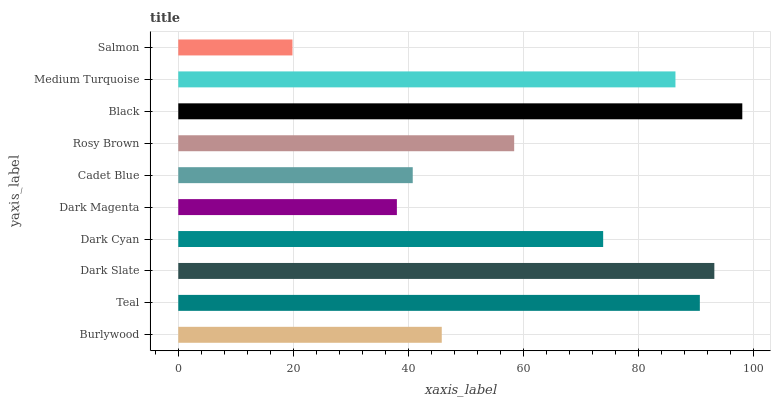Is Salmon the minimum?
Answer yes or no. Yes. Is Black the maximum?
Answer yes or no. Yes. Is Teal the minimum?
Answer yes or no. No. Is Teal the maximum?
Answer yes or no. No. Is Teal greater than Burlywood?
Answer yes or no. Yes. Is Burlywood less than Teal?
Answer yes or no. Yes. Is Burlywood greater than Teal?
Answer yes or no. No. Is Teal less than Burlywood?
Answer yes or no. No. Is Dark Cyan the high median?
Answer yes or no. Yes. Is Rosy Brown the low median?
Answer yes or no. Yes. Is Rosy Brown the high median?
Answer yes or no. No. Is Dark Slate the low median?
Answer yes or no. No. 